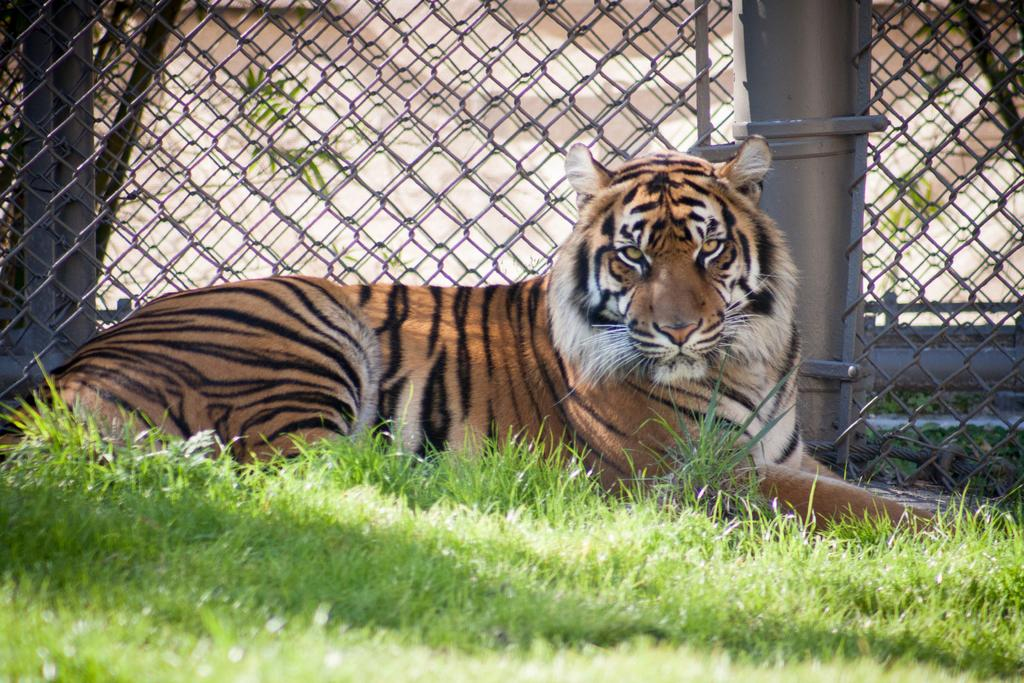What animal is in the image? There is a tiger in the image. What position is the tiger in? The tiger is sitting on the ground. What can be seen in the background of the image? There is a mesh in the background of the image. What type of vegetation is visible at the bottom of the image? There is grass visible at the bottom of the image. How many locks can be seen on the tiger in the image? There are no locks visible on the tiger in the image. What type of dirt is present on the tiger's fur in the image? There is no dirt present on the tiger's fur in the image. 